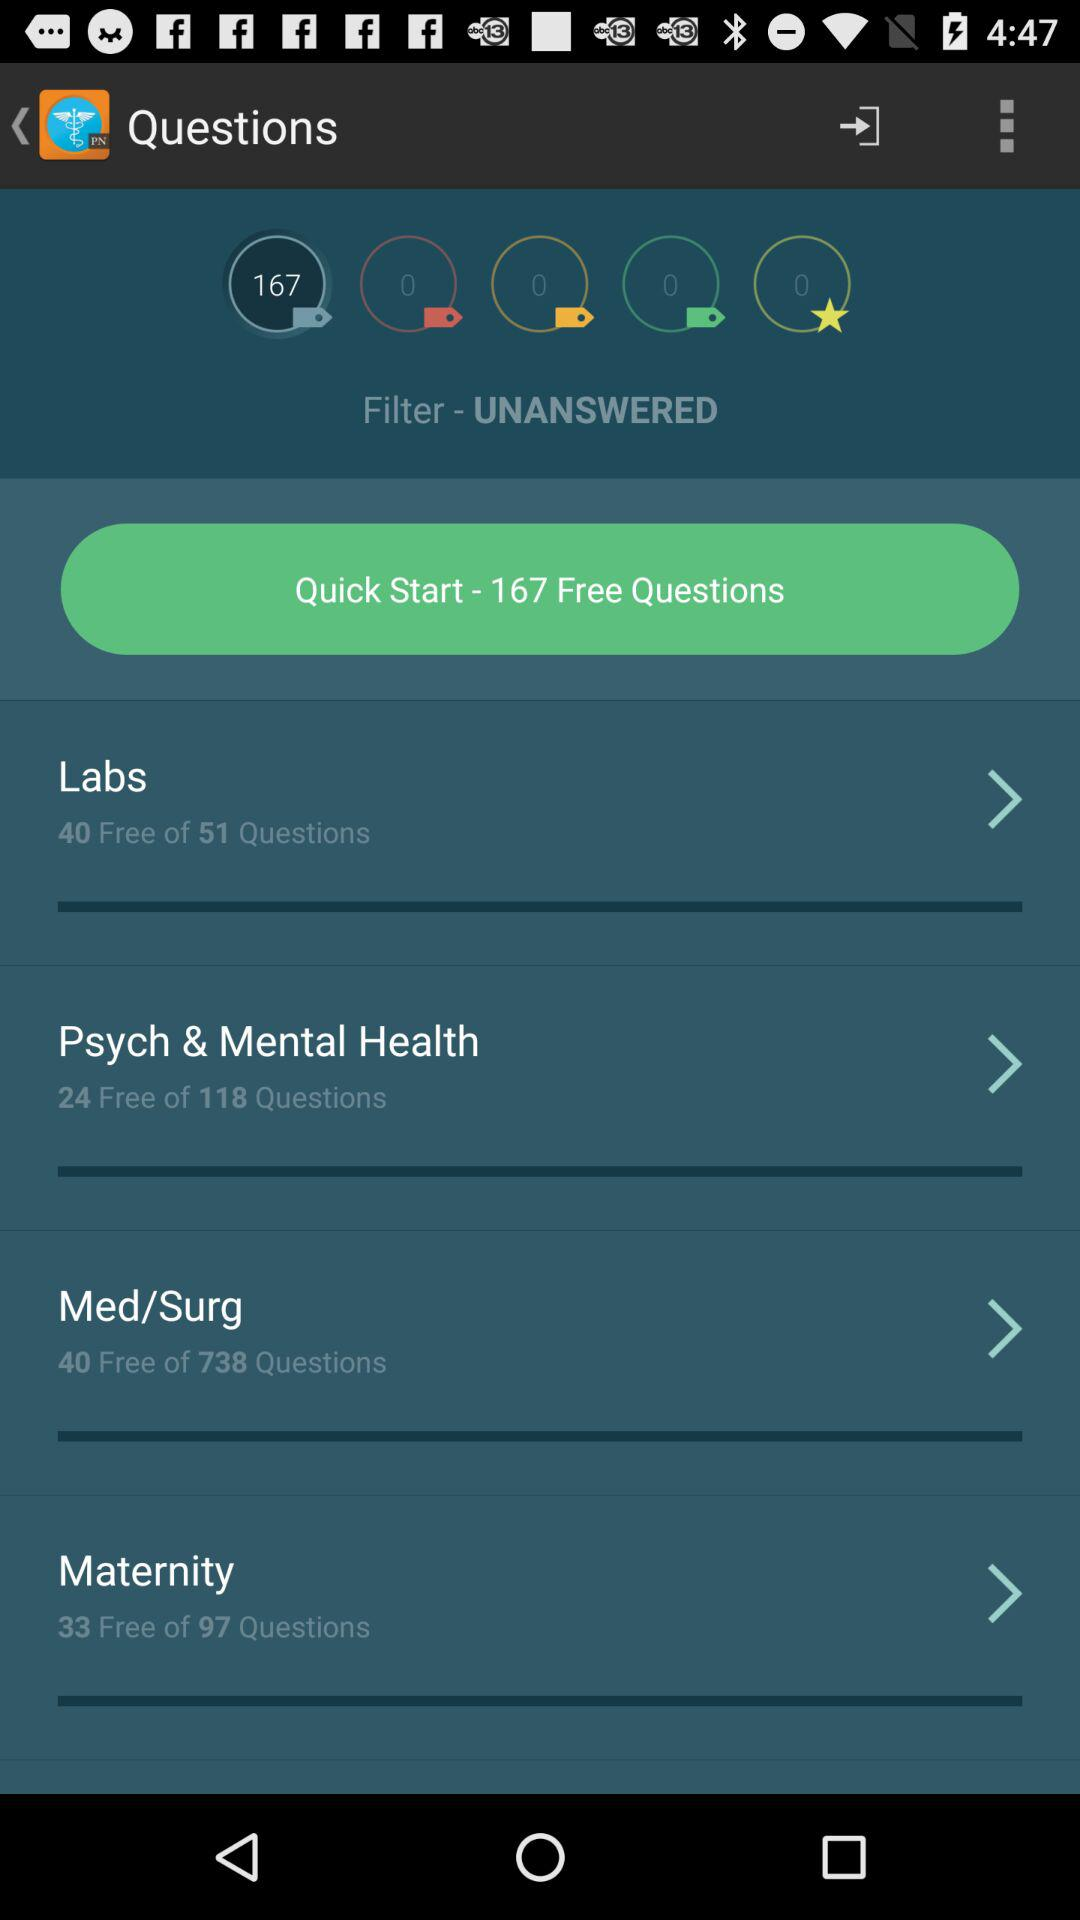Which course contains 97 questions? The course, which contains 97 questions, is Maternity. 